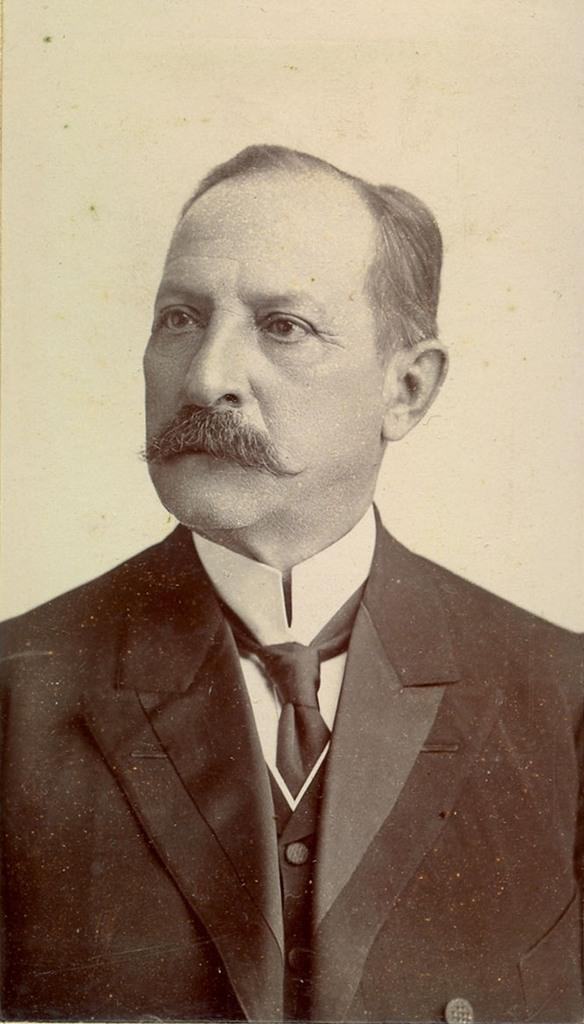Who or what is present in the image? There is a person in the image. What is the person wearing? The person is wearing a suit. What can be seen in the background of the image? There is a wall in the background of the image. What type of crayon is the person holding in the image? There is no crayon present in the image. How many sheep can be seen in the image? There are no sheep present in the image. 